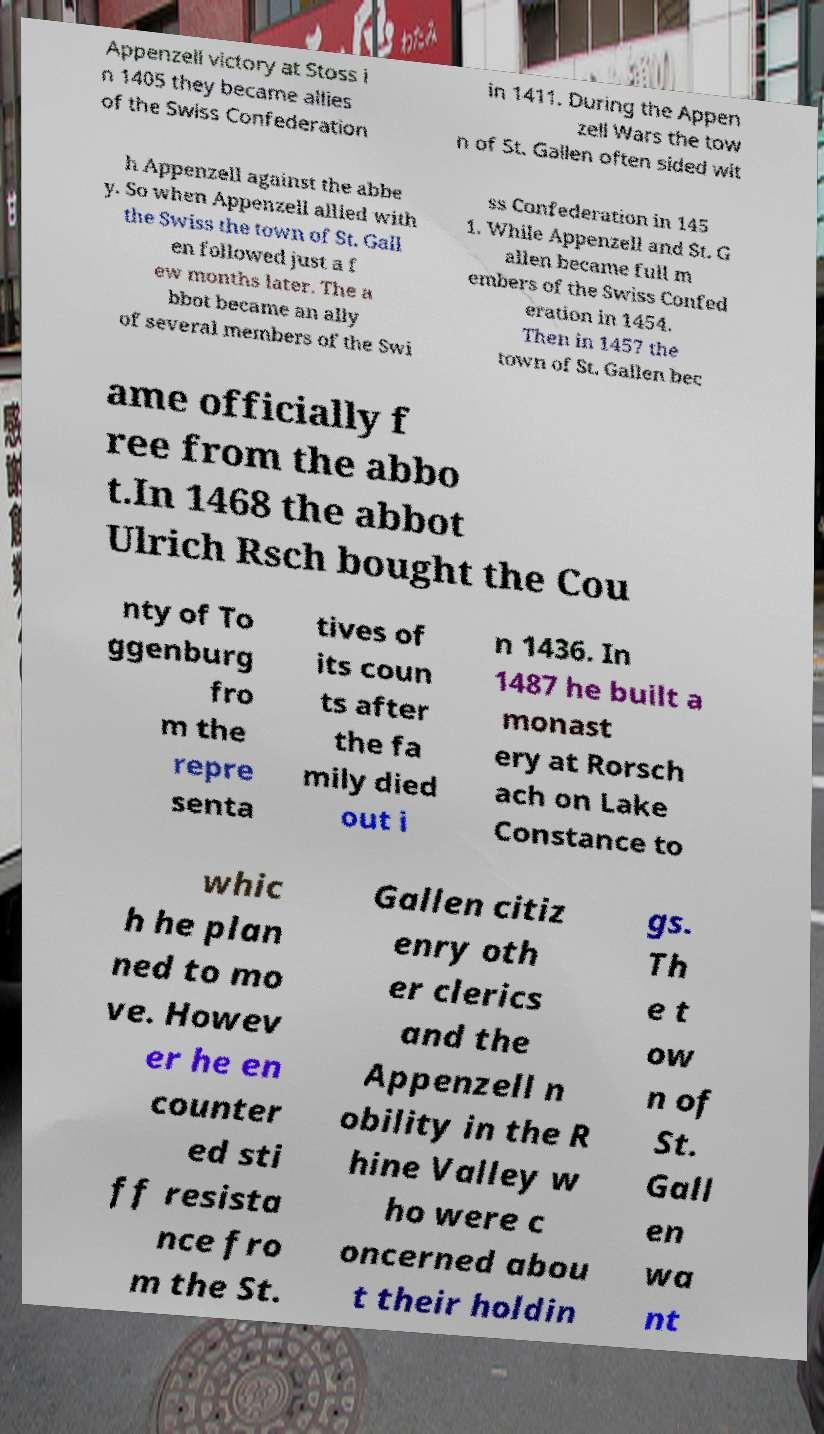For documentation purposes, I need the text within this image transcribed. Could you provide that? Appenzell victory at Stoss i n 1405 they became allies of the Swiss Confederation in 1411. During the Appen zell Wars the tow n of St. Gallen often sided wit h Appenzell against the abbe y. So when Appenzell allied with the Swiss the town of St. Gall en followed just a f ew months later. The a bbot became an ally of several members of the Swi ss Confederation in 145 1. While Appenzell and St. G allen became full m embers of the Swiss Confed eration in 1454. Then in 1457 the town of St. Gallen bec ame officially f ree from the abbo t.In 1468 the abbot Ulrich Rsch bought the Cou nty of To ggenburg fro m the repre senta tives of its coun ts after the fa mily died out i n 1436. In 1487 he built a monast ery at Rorsch ach on Lake Constance to whic h he plan ned to mo ve. Howev er he en counter ed sti ff resista nce fro m the St. Gallen citiz enry oth er clerics and the Appenzell n obility in the R hine Valley w ho were c oncerned abou t their holdin gs. Th e t ow n of St. Gall en wa nt 